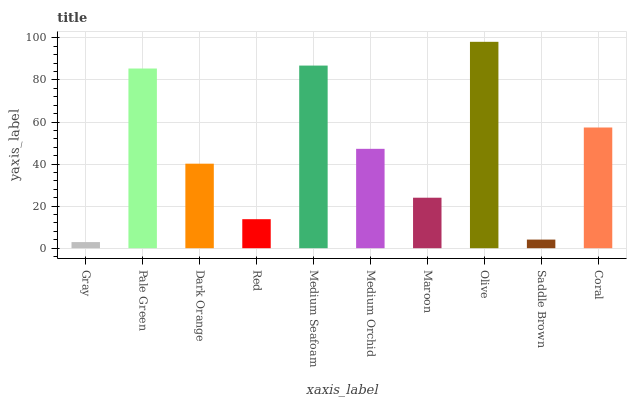Is Gray the minimum?
Answer yes or no. Yes. Is Olive the maximum?
Answer yes or no. Yes. Is Pale Green the minimum?
Answer yes or no. No. Is Pale Green the maximum?
Answer yes or no. No. Is Pale Green greater than Gray?
Answer yes or no. Yes. Is Gray less than Pale Green?
Answer yes or no. Yes. Is Gray greater than Pale Green?
Answer yes or no. No. Is Pale Green less than Gray?
Answer yes or no. No. Is Medium Orchid the high median?
Answer yes or no. Yes. Is Dark Orange the low median?
Answer yes or no. Yes. Is Maroon the high median?
Answer yes or no. No. Is Medium Orchid the low median?
Answer yes or no. No. 